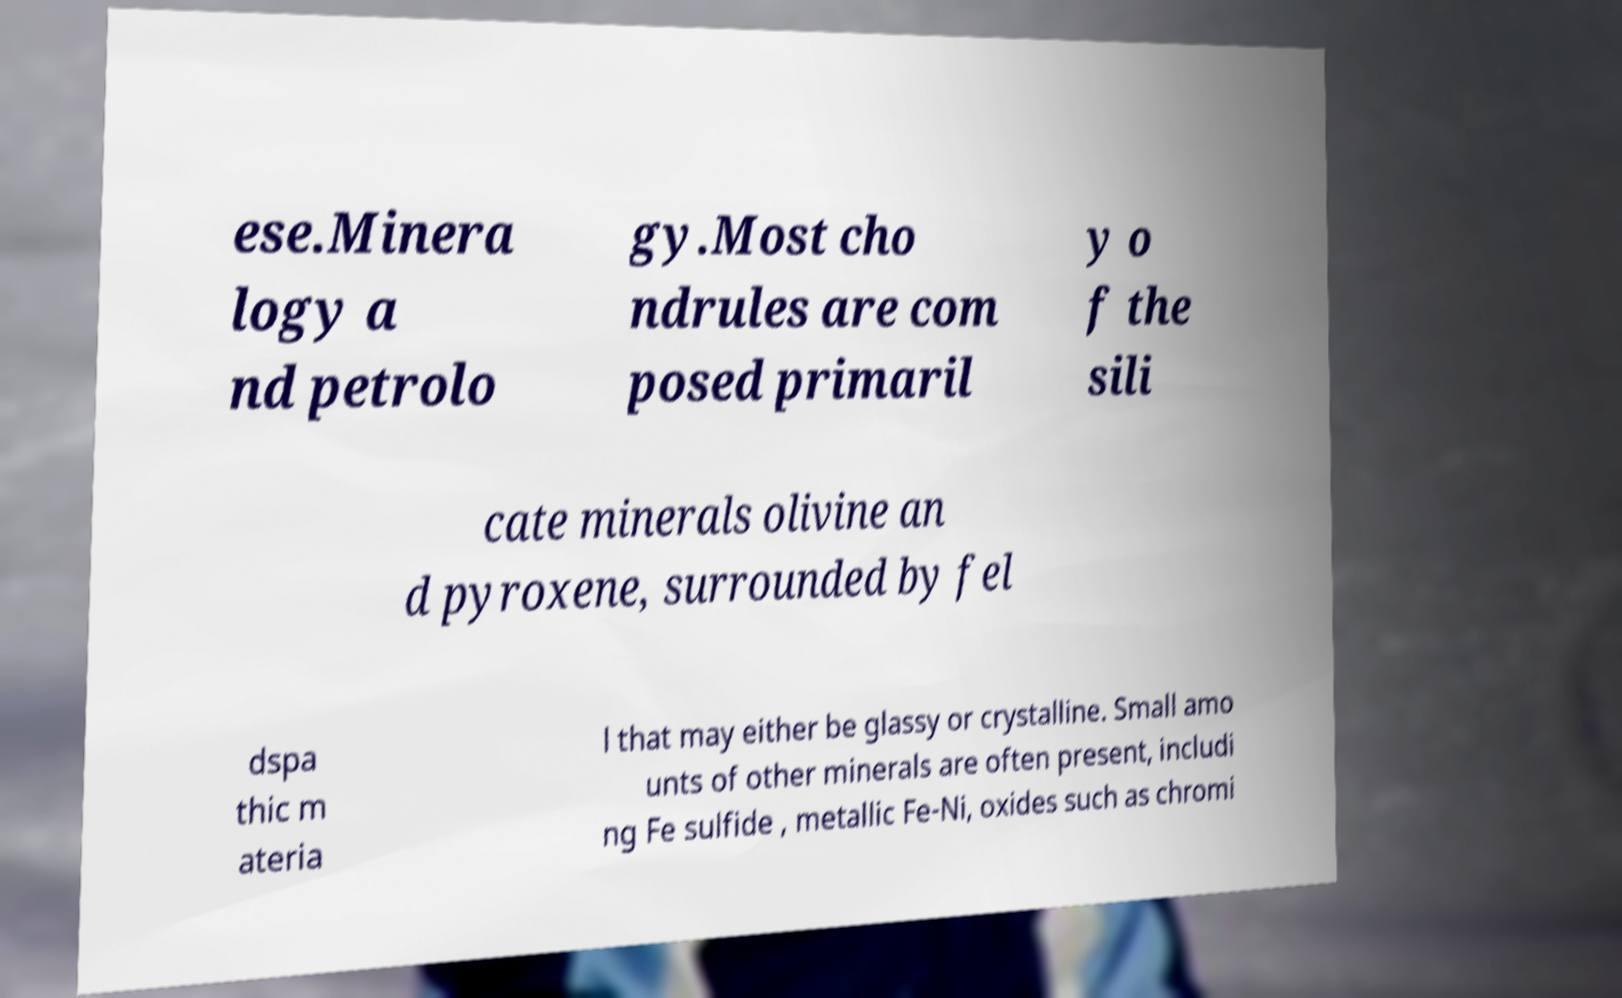Please read and relay the text visible in this image. What does it say? ese.Minera logy a nd petrolo gy.Most cho ndrules are com posed primaril y o f the sili cate minerals olivine an d pyroxene, surrounded by fel dspa thic m ateria l that may either be glassy or crystalline. Small amo unts of other minerals are often present, includi ng Fe sulfide , metallic Fe-Ni, oxides such as chromi 